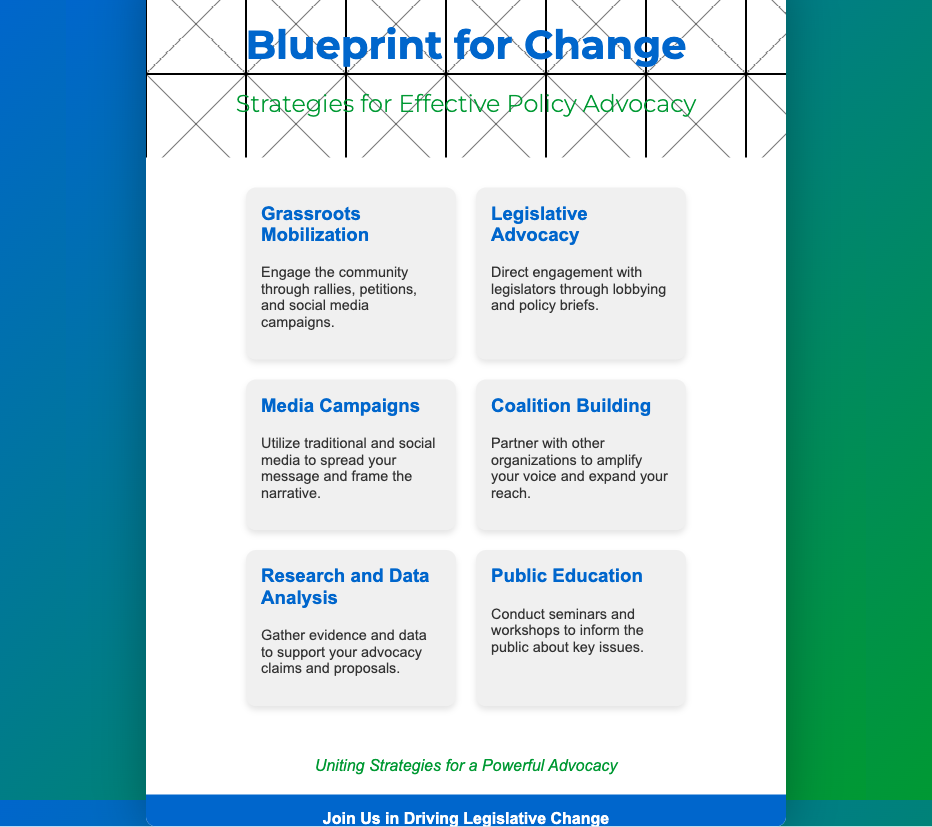What is the title of the book? The title of the book is prominently displayed at the top of the cover in large font.
Answer: Blueprint for Change Who is the intended audience for the book? The intended audience is determined by the advocacy strategies, suggesting it targets activists and organizations.
Answer: Non-profit organizations What color scheme is used on the book cover? The color scheme can be identified from the background gradient and title sections of the cover.
Answer: Blue and green What is one strategy highlighted on the book cover? The strategies are represented as puzzle pieces; one can be identified from the list.
Answer: Grassroots Mobilization How many advocacy strategies are presented on the cover? The number of puzzle pieces corresponds to the number of advocacy strategies laid out on the cover.
Answer: Six What is the tagline of the book? The tagline is displayed centrally under the puzzle pieces and summarizes the book's focus.
Answer: Uniting Strategies for a Powerful Advocacy What call to action is included on the cover? The call to action encourages audience participation and is found in the call to action section.
Answer: Join Us in Driving Legislative Change What type of information is provided in the contact info? The contact info section offers ways to connect with the organization behind the book.
Answer: Website and email What type of advocacy does "Legislative Advocacy" refer to? This strategy is explained in the puzzle piece on the cover, indicating its focus on one-to-one engagement.
Answer: Lobbying 